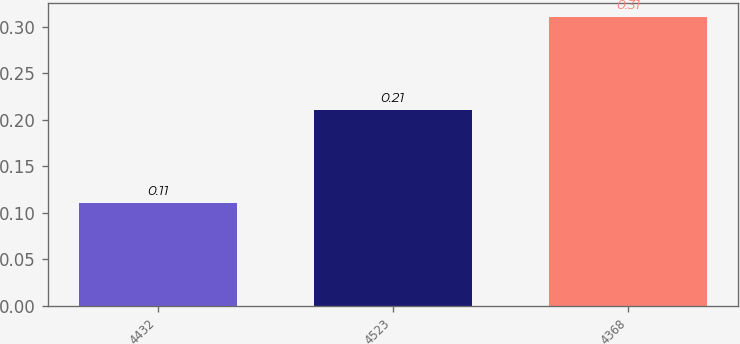Convert chart to OTSL. <chart><loc_0><loc_0><loc_500><loc_500><bar_chart><fcel>4432<fcel>4523<fcel>4368<nl><fcel>0.11<fcel>0.21<fcel>0.31<nl></chart> 